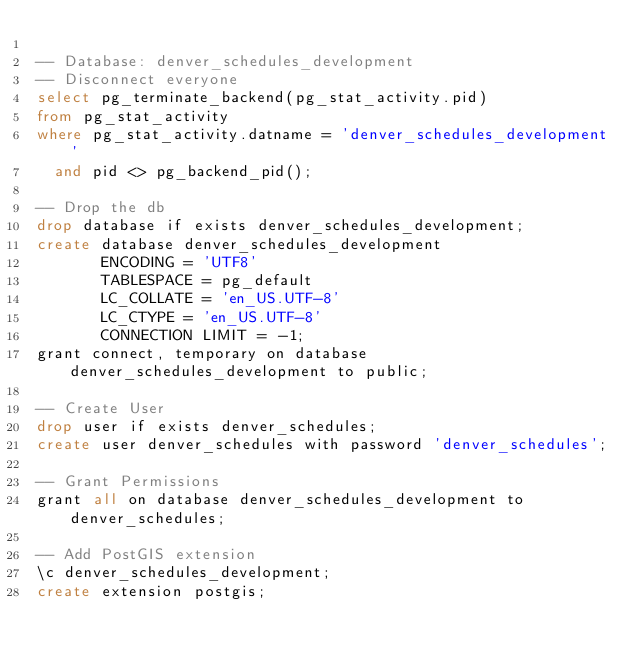<code> <loc_0><loc_0><loc_500><loc_500><_SQL_>
-- Database: denver_schedules_development
-- Disconnect everyone
select pg_terminate_backend(pg_stat_activity.pid)
from pg_stat_activity
where pg_stat_activity.datname = 'denver_schedules_development'
  and pid <> pg_backend_pid();

-- Drop the db
drop database if exists denver_schedules_development;
create database denver_schedules_development
       ENCODING = 'UTF8'
       TABLESPACE = pg_default
       LC_COLLATE = 'en_US.UTF-8'
       LC_CTYPE = 'en_US.UTF-8'
       CONNECTION LIMIT = -1;
grant connect, temporary on database denver_schedules_development to public;

-- Create User
drop user if exists denver_schedules;
create user denver_schedules with password 'denver_schedules';

-- Grant Permissions
grant all on database denver_schedules_development to denver_schedules;

-- Add PostGIS extension
\c denver_schedules_development;
create extension postgis;
</code> 